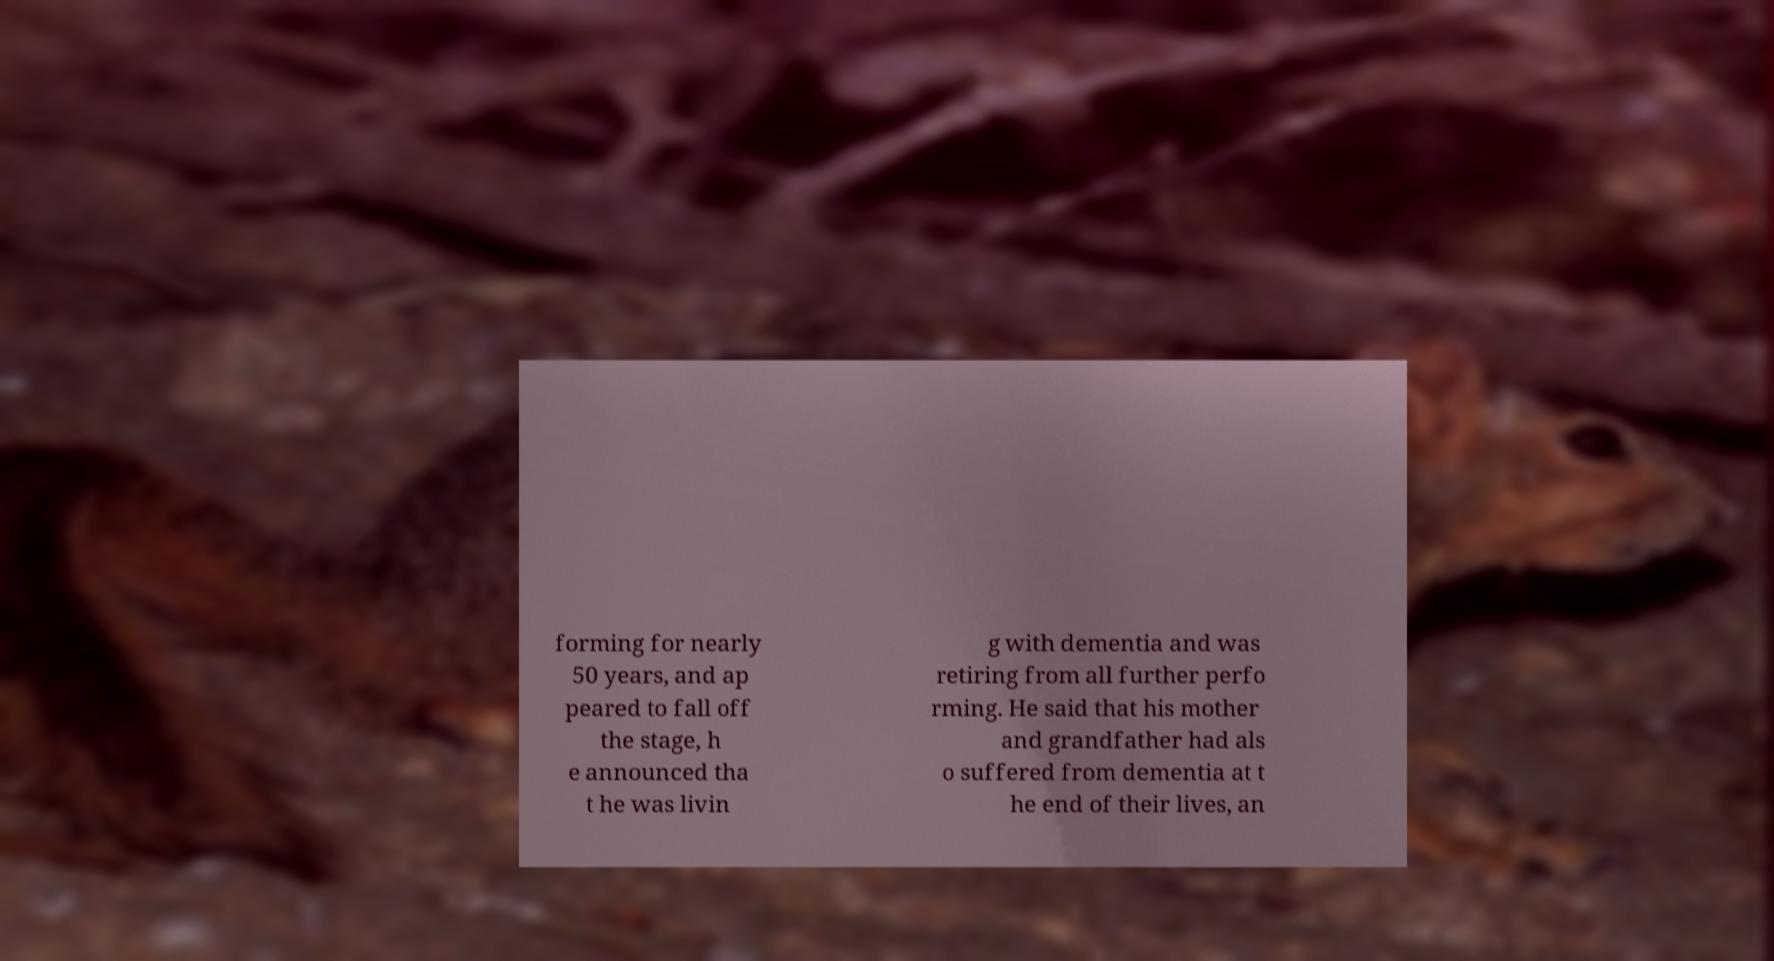What messages or text are displayed in this image? I need them in a readable, typed format. forming for nearly 50 years, and ap peared to fall off the stage, h e announced tha t he was livin g with dementia and was retiring from all further perfo rming. He said that his mother and grandfather had als o suffered from dementia at t he end of their lives, an 